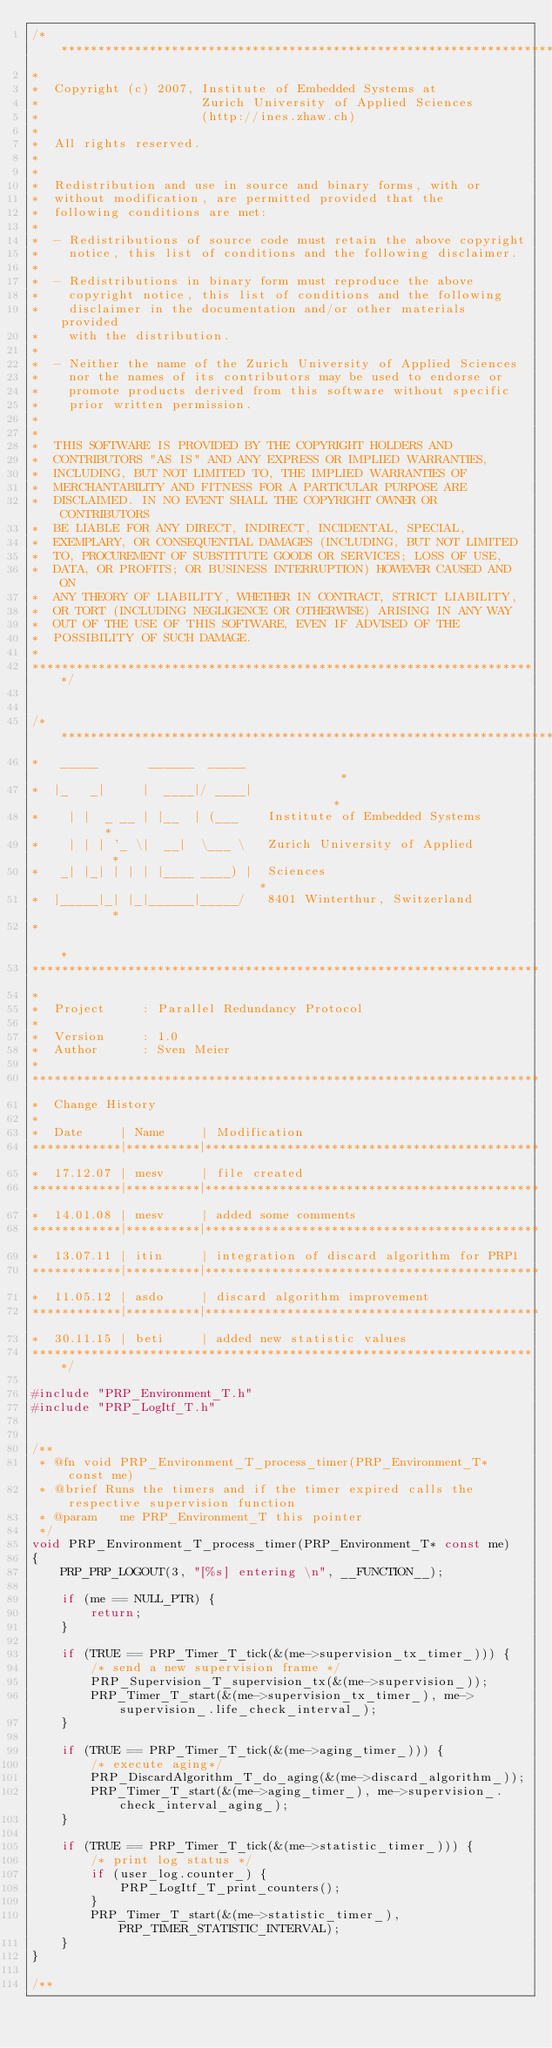Convert code to text. <code><loc_0><loc_0><loc_500><loc_500><_C_>/********************************************************************
*
*  Copyright (c) 2007, Institute of Embedded Systems at 
*                      Zurich University of Applied Sciences 
*                      (http://ines.zhaw.ch)
*
*  All rights reserved.
*
*
*  Redistribution and use in source and binary forms, with or  
*  without modification, are permitted provided that the 
*  following conditions are met:
*
*  - Redistributions of source code must retain the above copyright 
*    notice, this list of conditions and the following disclaimer. 
*
*  - Redistributions in binary form must reproduce the above 
*    copyright notice, this list of conditions and the following 
*    disclaimer in the documentation and/or other materials provided
*    with the distribution. 
*
*  - Neither the name of the Zurich University of Applied Sciences
*    nor the names of its contributors may be used to endorse or 
*    promote products derived from this software without specific 
*    prior written permission. 
*
*
*  THIS SOFTWARE IS PROVIDED BY THE COPYRIGHT HOLDERS AND 
*  CONTRIBUTORS "AS IS" AND ANY EXPRESS OR IMPLIED WARRANTIES, 
*  INCLUDING, BUT NOT LIMITED TO, THE IMPLIED WARRANTIES OF 
*  MERCHANTABILITY AND FITNESS FOR A PARTICULAR PURPOSE ARE 
*  DISCLAIMED. IN NO EVENT SHALL THE COPYRIGHT OWNER OR CONTRIBUTORS 
*  BE LIABLE FOR ANY DIRECT, INDIRECT, INCIDENTAL, SPECIAL, 
*  EXEMPLARY, OR CONSEQUENTIAL DAMAGES (INCLUDING, BUT NOT LIMITED 
*  TO, PROCUREMENT OF SUBSTITUTE GOODS OR SERVICES; LOSS OF USE, 
*  DATA, OR PROFITS; OR BUSINESS INTERRUPTION) HOWEVER CAUSED AND ON 
*  ANY THEORY OF LIABILITY, WHETHER IN CONTRACT, STRICT LIABILITY, 
*  OR TORT (INCLUDING NEGLIGENCE OR OTHERWISE) ARISING IN ANY WAY 
*  OUT OF THE USE OF THIS SOFTWARE, EVEN IF ADVISED OF THE 
*  POSSIBILITY OF SUCH DAMAGE.
*
*********************************************************************/


/********************************************************************
*   _____       ______  _____                                       *
*  |_   _|     |  ____|/ ____|                                      *
*    | |  _ __ | |__  | (___    Institute of Embedded Systems       *
*    | | | '_ \|  __|  \___ \   Zurich University of Applied        *
*   _| |_| | | | |____ ____) |  Sciences                            *
*  |_____|_| |_|______|_____/   8401 Winterthur, Switzerland        *
*                                                                   *
*********************************************************************
*
*  Project     : Parallel Redundancy Protocol
*
*  Version     : 1.0
*  Author      : Sven Meier
*
*********************************************************************
*  Change History
*
*  Date     | Name     | Modification
************|**********|*********************************************
*  17.12.07 | mesv     | file created
************|**********|*********************************************
*  14.01.08 | mesv     | added some comments
************|**********|*********************************************
*  13.07.11 | itin     | integration of discard algorithm for PRP1
************|**********|*********************************************
*  11.05.12 | asdo     | discard algorithm improvement
************|**********|*********************************************
*  30.11.15 | beti     | added new statistic values
*********************************************************************/

#include "PRP_Environment_T.h"
#include "PRP_LogItf_T.h"


/**
 * @fn void PRP_Environment_T_process_timer(PRP_Environment_T* const me)
 * @brief Runs the timers and if the timer expired calls the respective supervision function
 * @param   me PRP_Environment_T this pointer
 */
void PRP_Environment_T_process_timer(PRP_Environment_T* const me)
{
    PRP_PRP_LOGOUT(3, "[%s] entering \n", __FUNCTION__);

    if (me == NULL_PTR) {
        return;
    }

    if (TRUE == PRP_Timer_T_tick(&(me->supervision_tx_timer_))) {
        /* send a new supervision frame */
        PRP_Supervision_T_supervision_tx(&(me->supervision_)); 
        PRP_Timer_T_start(&(me->supervision_tx_timer_), me->supervision_.life_check_interval_);
    }

    if (TRUE == PRP_Timer_T_tick(&(me->aging_timer_))) {
        /* execute aging*/
        PRP_DiscardAlgorithm_T_do_aging(&(me->discard_algorithm_));
        PRP_Timer_T_start(&(me->aging_timer_), me->supervision_.check_interval_aging_);
    }

    if (TRUE == PRP_Timer_T_tick(&(me->statistic_timer_))) {
        /* print log status */
        if (user_log.counter_) {
            PRP_LogItf_T_print_counters();
        }
        PRP_Timer_T_start(&(me->statistic_timer_), PRP_TIMER_STATISTIC_INTERVAL);
    }
}

/**</code> 